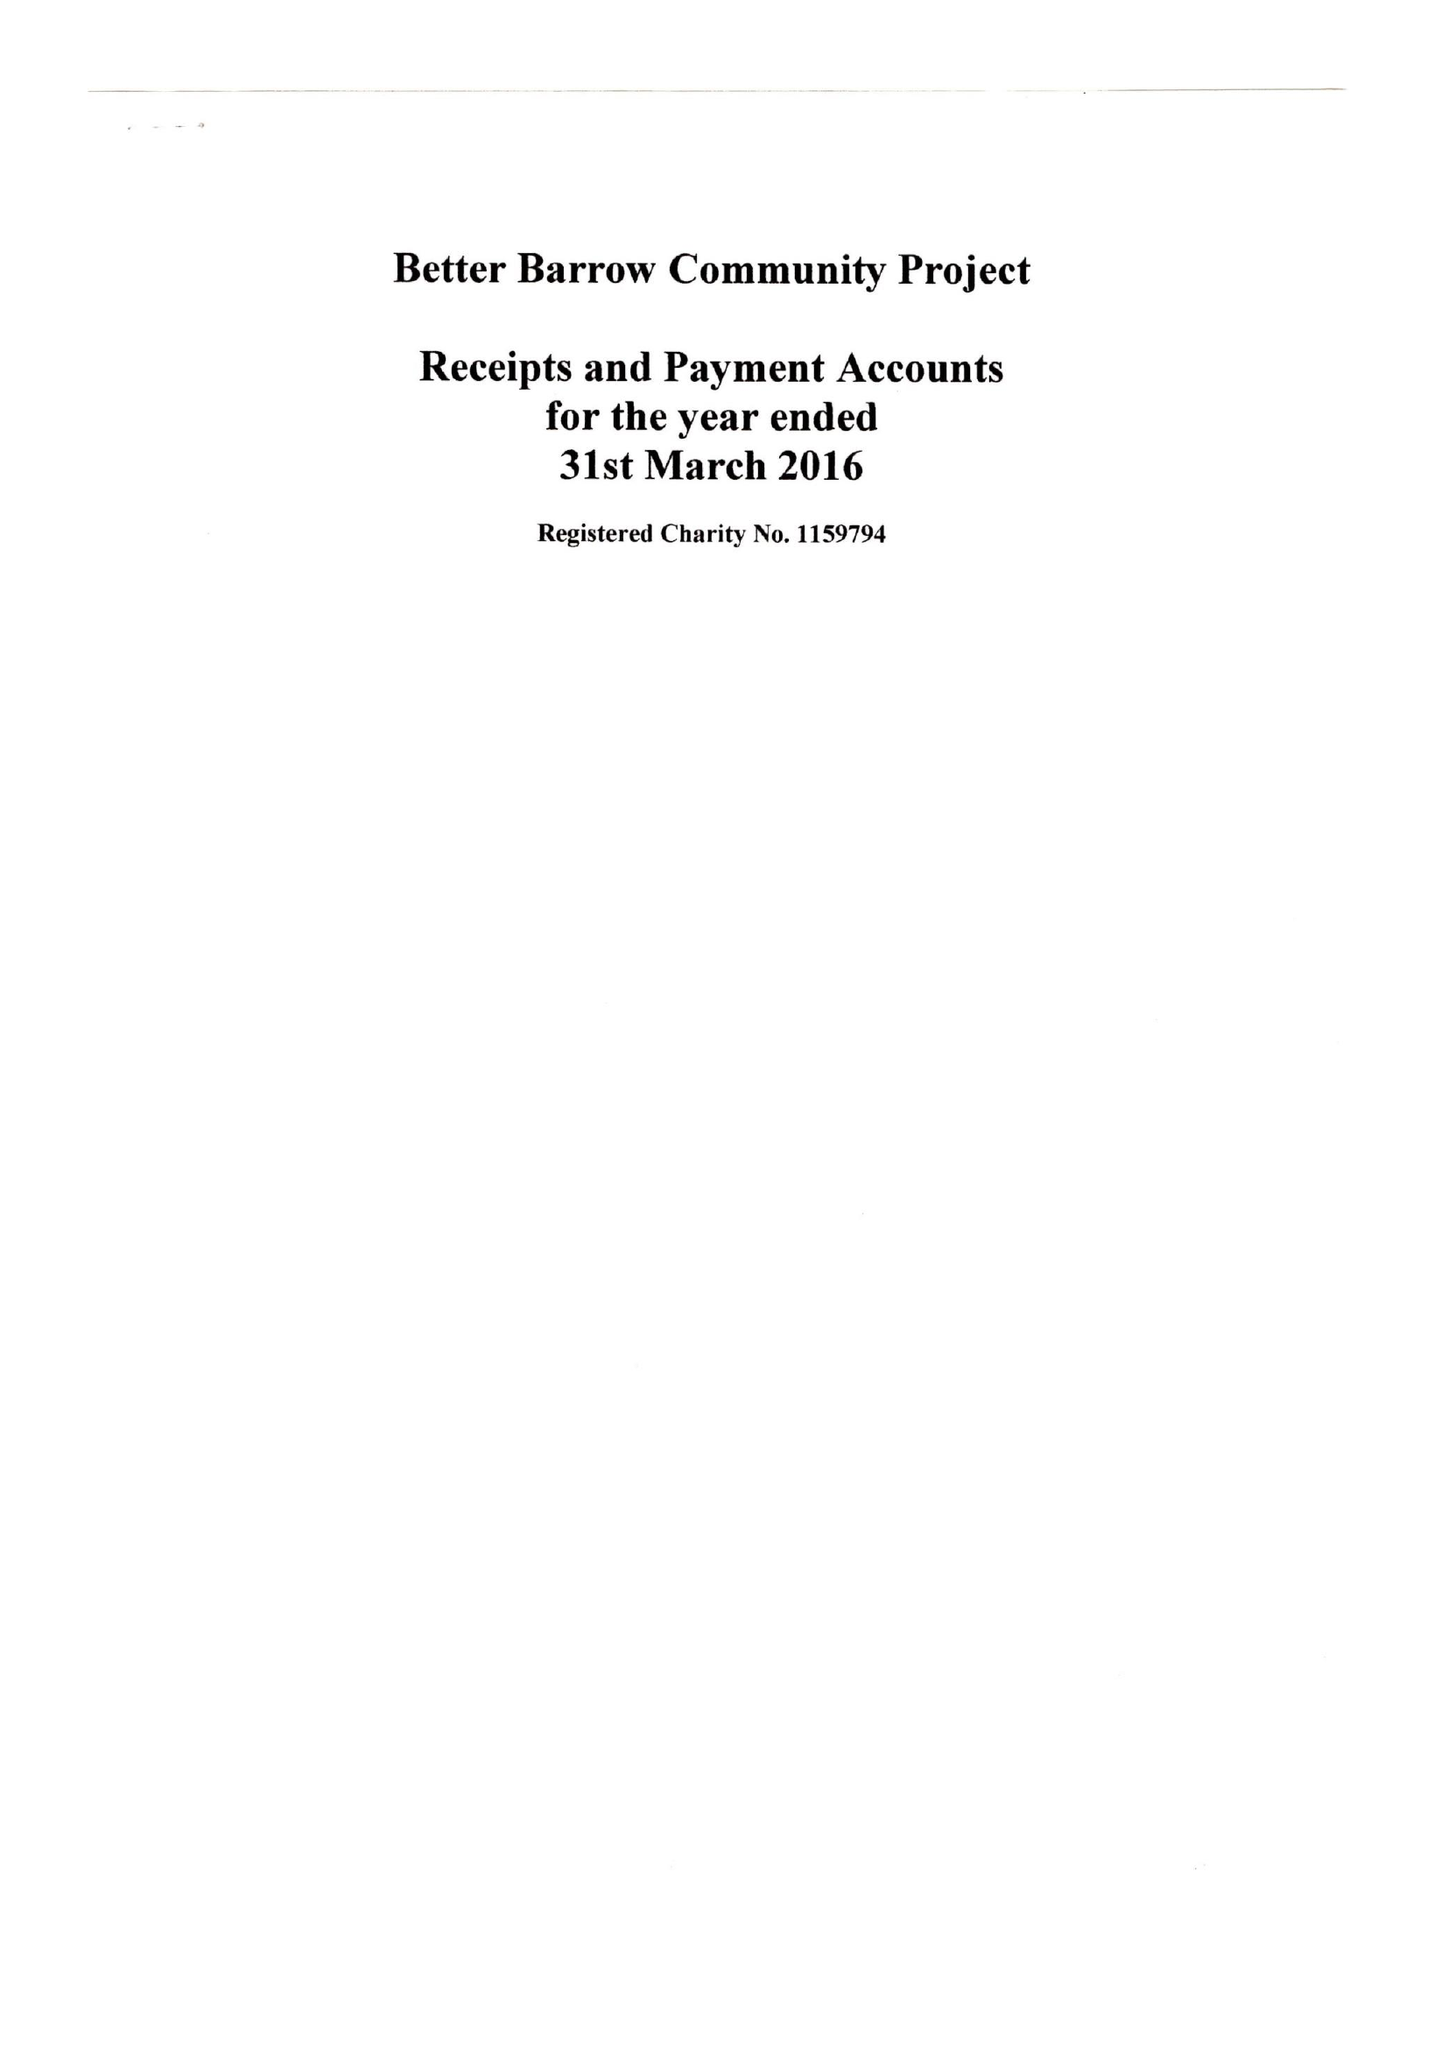What is the value for the report_date?
Answer the question using a single word or phrase. 2016-03-31 